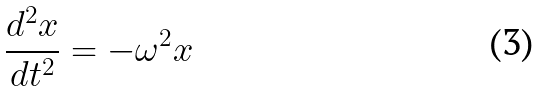<formula> <loc_0><loc_0><loc_500><loc_500>\frac { d ^ { 2 } x } { d t ^ { 2 } } = - \omega ^ { 2 } x</formula> 